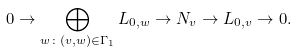<formula> <loc_0><loc_0><loc_500><loc_500>0 \to \bigoplus _ { w \colon ( v , w ) \in \Gamma _ { 1 } } L _ { 0 , w } \to N _ { v } \to L _ { 0 , v } \to 0 .</formula> 